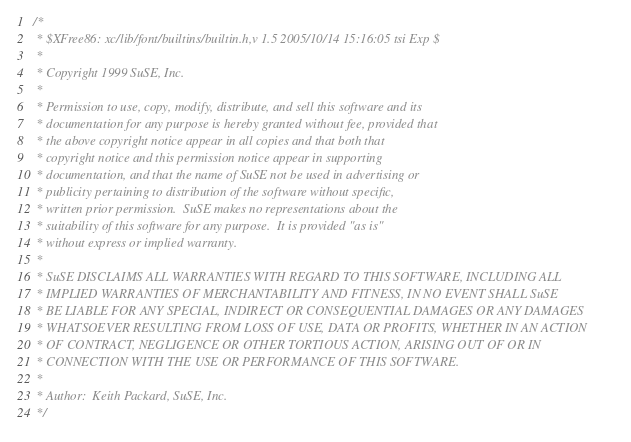<code> <loc_0><loc_0><loc_500><loc_500><_C_>/*
 * $XFree86: xc/lib/font/builtins/builtin.h,v 1.5 2005/10/14 15:16:05 tsi Exp $
 *
 * Copyright 1999 SuSE, Inc.
 *
 * Permission to use, copy, modify, distribute, and sell this software and its
 * documentation for any purpose is hereby granted without fee, provided that
 * the above copyright notice appear in all copies and that both that
 * copyright notice and this permission notice appear in supporting
 * documentation, and that the name of SuSE not be used in advertising or
 * publicity pertaining to distribution of the software without specific,
 * written prior permission.  SuSE makes no representations about the
 * suitability of this software for any purpose.  It is provided "as is"
 * without express or implied warranty.
 *
 * SuSE DISCLAIMS ALL WARRANTIES WITH REGARD TO THIS SOFTWARE, INCLUDING ALL
 * IMPLIED WARRANTIES OF MERCHANTABILITY AND FITNESS, IN NO EVENT SHALL SuSE
 * BE LIABLE FOR ANY SPECIAL, INDIRECT OR CONSEQUENTIAL DAMAGES OR ANY DAMAGES
 * WHATSOEVER RESULTING FROM LOSS OF USE, DATA OR PROFITS, WHETHER IN AN ACTION
 * OF CONTRACT, NEGLIGENCE OR OTHER TORTIOUS ACTION, ARISING OUT OF OR IN
 * CONNECTION WITH THE USE OR PERFORMANCE OF THIS SOFTWARE.
 *
 * Author:  Keith Packard, SuSE, Inc.
 */
</code> 